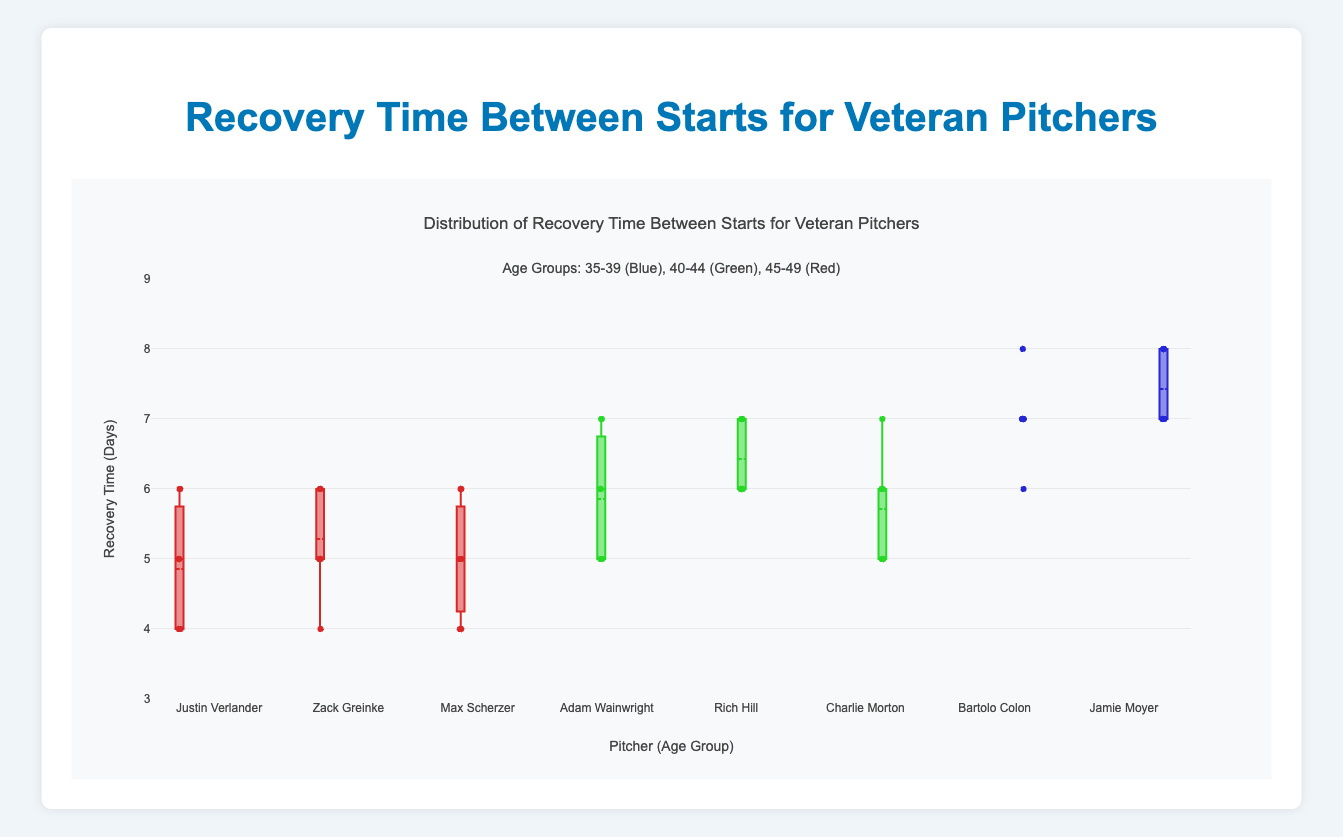What is the title of the box plot? The title is usually located at the top of the figure. In this case, it is clearly mentioned.
Answer: Distribution of Recovery Time Between Starts for Veteran Pitchers What is the range of the y-axis in the plot? The range is indicated by the axis labels and tick marks on the left side of the plot.
Answer: 3 to 9 Which pitcher in the 40-44 age group has the highest median recovery time? Look for the box plot with the highest median line within the 40-44 age group section.
Answer: Rich Hill What are the colors representing different age groups in the plot? The colors and corresponding age groups are mentioned in the title annotations.
Answer: 35-39 (Blue), 40-44 (Green), 45-49 (Red) How many total pitchers are shown in the plot? Count the number of distinct box plots, each representing a pitcher.
Answer: 8 Which age group has the highest maximum recovery time recorded, and what is that time? Look for the highest whisker end among all age groups.
Answer: 45-49, 8 days What is the median recovery time for Max Scherzer? Identify the line in the middle of Max Scherzer's box plot.
Answer: 5 days Who has the largest interquartile range (IQR) in the 35-39 age group? Look for the largest box height in the 35-39 age group; IQR is the distance between the top and bottom of the box.
Answer: Justin Verlander Which pitcher has the most consistent recovery time in the 40-44 age group? Look for the smallest overall box and whisker length in the 40-44 age group.
Answer: Charlie Morton Compare the median recovery times between Justin Verlander and Bartolo Colon. Who has a higher median recovery time and by how much? Identify the medians of both pitchers and calculate the difference.
Answer: Bartolo Colon by 2 days 